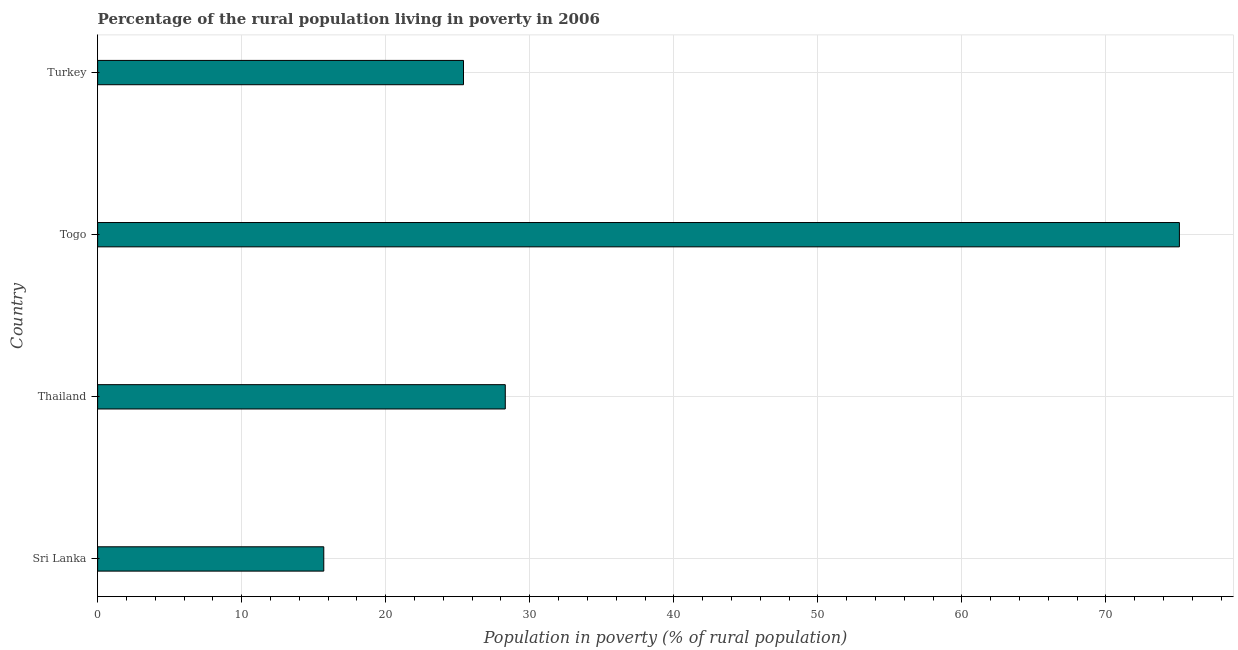Does the graph contain any zero values?
Give a very brief answer. No. What is the title of the graph?
Keep it short and to the point. Percentage of the rural population living in poverty in 2006. What is the label or title of the X-axis?
Ensure brevity in your answer.  Population in poverty (% of rural population). What is the percentage of rural population living below poverty line in Togo?
Keep it short and to the point. 75.1. Across all countries, what is the maximum percentage of rural population living below poverty line?
Give a very brief answer. 75.1. Across all countries, what is the minimum percentage of rural population living below poverty line?
Your answer should be very brief. 15.7. In which country was the percentage of rural population living below poverty line maximum?
Give a very brief answer. Togo. In which country was the percentage of rural population living below poverty line minimum?
Give a very brief answer. Sri Lanka. What is the sum of the percentage of rural population living below poverty line?
Give a very brief answer. 144.5. What is the difference between the percentage of rural population living below poverty line in Sri Lanka and Turkey?
Keep it short and to the point. -9.7. What is the average percentage of rural population living below poverty line per country?
Provide a short and direct response. 36.12. What is the median percentage of rural population living below poverty line?
Keep it short and to the point. 26.85. What is the ratio of the percentage of rural population living below poverty line in Sri Lanka to that in Togo?
Give a very brief answer. 0.21. Is the percentage of rural population living below poverty line in Sri Lanka less than that in Togo?
Make the answer very short. Yes. What is the difference between the highest and the second highest percentage of rural population living below poverty line?
Make the answer very short. 46.8. Is the sum of the percentage of rural population living below poverty line in Sri Lanka and Thailand greater than the maximum percentage of rural population living below poverty line across all countries?
Give a very brief answer. No. What is the difference between the highest and the lowest percentage of rural population living below poverty line?
Keep it short and to the point. 59.4. Are all the bars in the graph horizontal?
Keep it short and to the point. Yes. Are the values on the major ticks of X-axis written in scientific E-notation?
Keep it short and to the point. No. What is the Population in poverty (% of rural population) in Thailand?
Provide a succinct answer. 28.3. What is the Population in poverty (% of rural population) of Togo?
Offer a terse response. 75.1. What is the Population in poverty (% of rural population) of Turkey?
Make the answer very short. 25.4. What is the difference between the Population in poverty (% of rural population) in Sri Lanka and Thailand?
Ensure brevity in your answer.  -12.6. What is the difference between the Population in poverty (% of rural population) in Sri Lanka and Togo?
Your response must be concise. -59.4. What is the difference between the Population in poverty (% of rural population) in Sri Lanka and Turkey?
Your response must be concise. -9.7. What is the difference between the Population in poverty (% of rural population) in Thailand and Togo?
Provide a short and direct response. -46.8. What is the difference between the Population in poverty (% of rural population) in Togo and Turkey?
Keep it short and to the point. 49.7. What is the ratio of the Population in poverty (% of rural population) in Sri Lanka to that in Thailand?
Keep it short and to the point. 0.56. What is the ratio of the Population in poverty (% of rural population) in Sri Lanka to that in Togo?
Give a very brief answer. 0.21. What is the ratio of the Population in poverty (% of rural population) in Sri Lanka to that in Turkey?
Provide a short and direct response. 0.62. What is the ratio of the Population in poverty (% of rural population) in Thailand to that in Togo?
Offer a very short reply. 0.38. What is the ratio of the Population in poverty (% of rural population) in Thailand to that in Turkey?
Your answer should be compact. 1.11. What is the ratio of the Population in poverty (% of rural population) in Togo to that in Turkey?
Keep it short and to the point. 2.96. 